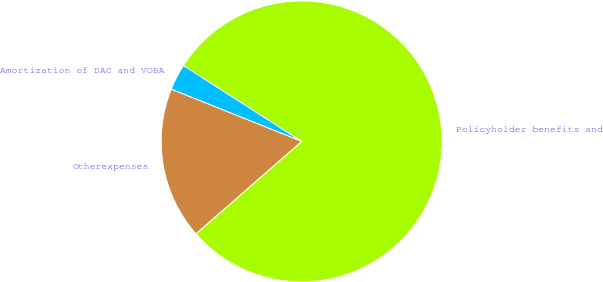<chart> <loc_0><loc_0><loc_500><loc_500><pie_chart><fcel>Policyholder benefits and<fcel>Amortization of DAC and VOBA<fcel>Otherexpenses<nl><fcel>79.49%<fcel>3.02%<fcel>17.49%<nl></chart> 